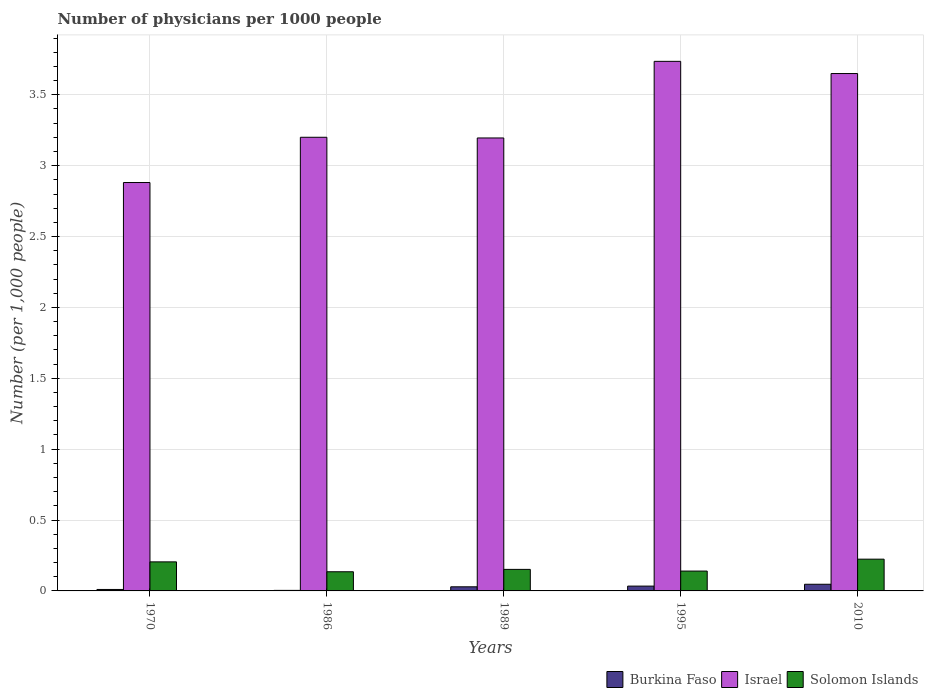What is the number of physicians in Solomon Islands in 2010?
Your answer should be compact. 0.22. Across all years, what is the maximum number of physicians in Burkina Faso?
Your response must be concise. 0.05. Across all years, what is the minimum number of physicians in Israel?
Keep it short and to the point. 2.88. What is the total number of physicians in Solomon Islands in the graph?
Offer a terse response. 0.86. What is the difference between the number of physicians in Solomon Islands in 1995 and that in 2010?
Provide a succinct answer. -0.08. What is the difference between the number of physicians in Solomon Islands in 2010 and the number of physicians in Burkina Faso in 1970?
Keep it short and to the point. 0.21. What is the average number of physicians in Solomon Islands per year?
Your response must be concise. 0.17. In the year 1986, what is the difference between the number of physicians in Burkina Faso and number of physicians in Israel?
Make the answer very short. -3.2. What is the ratio of the number of physicians in Solomon Islands in 1989 to that in 2010?
Make the answer very short. 0.68. Is the number of physicians in Burkina Faso in 1970 less than that in 1986?
Give a very brief answer. No. What is the difference between the highest and the second highest number of physicians in Israel?
Your answer should be very brief. 0.09. What is the difference between the highest and the lowest number of physicians in Solomon Islands?
Provide a short and direct response. 0.09. In how many years, is the number of physicians in Burkina Faso greater than the average number of physicians in Burkina Faso taken over all years?
Ensure brevity in your answer.  3. What does the 1st bar from the left in 1989 represents?
Offer a terse response. Burkina Faso. What does the 3rd bar from the right in 1989 represents?
Ensure brevity in your answer.  Burkina Faso. Is it the case that in every year, the sum of the number of physicians in Burkina Faso and number of physicians in Israel is greater than the number of physicians in Solomon Islands?
Give a very brief answer. Yes. How many bars are there?
Make the answer very short. 15. Are all the bars in the graph horizontal?
Your answer should be compact. No. Does the graph contain grids?
Your response must be concise. Yes. How are the legend labels stacked?
Ensure brevity in your answer.  Horizontal. What is the title of the graph?
Your response must be concise. Number of physicians per 1000 people. What is the label or title of the Y-axis?
Offer a terse response. Number (per 1,0 people). What is the Number (per 1,000 people) in Burkina Faso in 1970?
Offer a terse response. 0.01. What is the Number (per 1,000 people) of Israel in 1970?
Give a very brief answer. 2.88. What is the Number (per 1,000 people) in Solomon Islands in 1970?
Give a very brief answer. 0.2. What is the Number (per 1,000 people) of Burkina Faso in 1986?
Provide a short and direct response. 0. What is the Number (per 1,000 people) of Israel in 1986?
Make the answer very short. 3.2. What is the Number (per 1,000 people) in Solomon Islands in 1986?
Your answer should be very brief. 0.14. What is the Number (per 1,000 people) of Burkina Faso in 1989?
Your response must be concise. 0.03. What is the Number (per 1,000 people) in Israel in 1989?
Make the answer very short. 3.2. What is the Number (per 1,000 people) of Solomon Islands in 1989?
Your answer should be very brief. 0.15. What is the Number (per 1,000 people) of Burkina Faso in 1995?
Provide a succinct answer. 0.03. What is the Number (per 1,000 people) in Israel in 1995?
Your response must be concise. 3.74. What is the Number (per 1,000 people) of Solomon Islands in 1995?
Provide a short and direct response. 0.14. What is the Number (per 1,000 people) in Burkina Faso in 2010?
Provide a short and direct response. 0.05. What is the Number (per 1,000 people) in Israel in 2010?
Keep it short and to the point. 3.65. What is the Number (per 1,000 people) of Solomon Islands in 2010?
Your answer should be compact. 0.22. Across all years, what is the maximum Number (per 1,000 people) of Burkina Faso?
Provide a short and direct response. 0.05. Across all years, what is the maximum Number (per 1,000 people) of Israel?
Make the answer very short. 3.74. Across all years, what is the maximum Number (per 1,000 people) in Solomon Islands?
Ensure brevity in your answer.  0.22. Across all years, what is the minimum Number (per 1,000 people) of Burkina Faso?
Give a very brief answer. 0. Across all years, what is the minimum Number (per 1,000 people) of Israel?
Provide a short and direct response. 2.88. Across all years, what is the minimum Number (per 1,000 people) of Solomon Islands?
Offer a very short reply. 0.14. What is the total Number (per 1,000 people) in Burkina Faso in the graph?
Make the answer very short. 0.12. What is the total Number (per 1,000 people) of Israel in the graph?
Your answer should be very brief. 16.66. What is the total Number (per 1,000 people) in Solomon Islands in the graph?
Offer a terse response. 0.86. What is the difference between the Number (per 1,000 people) in Burkina Faso in 1970 and that in 1986?
Ensure brevity in your answer.  0.01. What is the difference between the Number (per 1,000 people) in Israel in 1970 and that in 1986?
Offer a terse response. -0.32. What is the difference between the Number (per 1,000 people) in Solomon Islands in 1970 and that in 1986?
Ensure brevity in your answer.  0.07. What is the difference between the Number (per 1,000 people) of Burkina Faso in 1970 and that in 1989?
Make the answer very short. -0.02. What is the difference between the Number (per 1,000 people) of Israel in 1970 and that in 1989?
Make the answer very short. -0.31. What is the difference between the Number (per 1,000 people) in Solomon Islands in 1970 and that in 1989?
Provide a succinct answer. 0.05. What is the difference between the Number (per 1,000 people) of Burkina Faso in 1970 and that in 1995?
Offer a very short reply. -0.02. What is the difference between the Number (per 1,000 people) of Israel in 1970 and that in 1995?
Ensure brevity in your answer.  -0.85. What is the difference between the Number (per 1,000 people) of Solomon Islands in 1970 and that in 1995?
Give a very brief answer. 0.07. What is the difference between the Number (per 1,000 people) of Burkina Faso in 1970 and that in 2010?
Keep it short and to the point. -0.04. What is the difference between the Number (per 1,000 people) in Israel in 1970 and that in 2010?
Provide a short and direct response. -0.77. What is the difference between the Number (per 1,000 people) of Solomon Islands in 1970 and that in 2010?
Your answer should be compact. -0.02. What is the difference between the Number (per 1,000 people) in Burkina Faso in 1986 and that in 1989?
Provide a short and direct response. -0.03. What is the difference between the Number (per 1,000 people) in Israel in 1986 and that in 1989?
Offer a terse response. 0. What is the difference between the Number (per 1,000 people) in Solomon Islands in 1986 and that in 1989?
Keep it short and to the point. -0.02. What is the difference between the Number (per 1,000 people) in Burkina Faso in 1986 and that in 1995?
Ensure brevity in your answer.  -0.03. What is the difference between the Number (per 1,000 people) of Israel in 1986 and that in 1995?
Give a very brief answer. -0.54. What is the difference between the Number (per 1,000 people) in Solomon Islands in 1986 and that in 1995?
Make the answer very short. -0. What is the difference between the Number (per 1,000 people) of Burkina Faso in 1986 and that in 2010?
Your answer should be very brief. -0.04. What is the difference between the Number (per 1,000 people) in Israel in 1986 and that in 2010?
Provide a short and direct response. -0.45. What is the difference between the Number (per 1,000 people) in Solomon Islands in 1986 and that in 2010?
Your answer should be compact. -0.09. What is the difference between the Number (per 1,000 people) of Burkina Faso in 1989 and that in 1995?
Make the answer very short. -0.01. What is the difference between the Number (per 1,000 people) of Israel in 1989 and that in 1995?
Provide a short and direct response. -0.54. What is the difference between the Number (per 1,000 people) in Solomon Islands in 1989 and that in 1995?
Your answer should be compact. 0.01. What is the difference between the Number (per 1,000 people) in Burkina Faso in 1989 and that in 2010?
Your response must be concise. -0.02. What is the difference between the Number (per 1,000 people) in Israel in 1989 and that in 2010?
Keep it short and to the point. -0.45. What is the difference between the Number (per 1,000 people) of Solomon Islands in 1989 and that in 2010?
Your response must be concise. -0.07. What is the difference between the Number (per 1,000 people) of Burkina Faso in 1995 and that in 2010?
Offer a terse response. -0.01. What is the difference between the Number (per 1,000 people) of Israel in 1995 and that in 2010?
Make the answer very short. 0.09. What is the difference between the Number (per 1,000 people) in Solomon Islands in 1995 and that in 2010?
Ensure brevity in your answer.  -0.08. What is the difference between the Number (per 1,000 people) of Burkina Faso in 1970 and the Number (per 1,000 people) of Israel in 1986?
Provide a short and direct response. -3.19. What is the difference between the Number (per 1,000 people) of Burkina Faso in 1970 and the Number (per 1,000 people) of Solomon Islands in 1986?
Give a very brief answer. -0.12. What is the difference between the Number (per 1,000 people) in Israel in 1970 and the Number (per 1,000 people) in Solomon Islands in 1986?
Offer a terse response. 2.75. What is the difference between the Number (per 1,000 people) of Burkina Faso in 1970 and the Number (per 1,000 people) of Israel in 1989?
Your answer should be very brief. -3.19. What is the difference between the Number (per 1,000 people) in Burkina Faso in 1970 and the Number (per 1,000 people) in Solomon Islands in 1989?
Provide a succinct answer. -0.14. What is the difference between the Number (per 1,000 people) of Israel in 1970 and the Number (per 1,000 people) of Solomon Islands in 1989?
Provide a succinct answer. 2.73. What is the difference between the Number (per 1,000 people) of Burkina Faso in 1970 and the Number (per 1,000 people) of Israel in 1995?
Offer a very short reply. -3.73. What is the difference between the Number (per 1,000 people) of Burkina Faso in 1970 and the Number (per 1,000 people) of Solomon Islands in 1995?
Offer a very short reply. -0.13. What is the difference between the Number (per 1,000 people) in Israel in 1970 and the Number (per 1,000 people) in Solomon Islands in 1995?
Your response must be concise. 2.74. What is the difference between the Number (per 1,000 people) in Burkina Faso in 1970 and the Number (per 1,000 people) in Israel in 2010?
Your response must be concise. -3.64. What is the difference between the Number (per 1,000 people) of Burkina Faso in 1970 and the Number (per 1,000 people) of Solomon Islands in 2010?
Ensure brevity in your answer.  -0.21. What is the difference between the Number (per 1,000 people) of Israel in 1970 and the Number (per 1,000 people) of Solomon Islands in 2010?
Your answer should be compact. 2.66. What is the difference between the Number (per 1,000 people) in Burkina Faso in 1986 and the Number (per 1,000 people) in Israel in 1989?
Offer a very short reply. -3.19. What is the difference between the Number (per 1,000 people) in Burkina Faso in 1986 and the Number (per 1,000 people) in Solomon Islands in 1989?
Offer a very short reply. -0.15. What is the difference between the Number (per 1,000 people) in Israel in 1986 and the Number (per 1,000 people) in Solomon Islands in 1989?
Give a very brief answer. 3.05. What is the difference between the Number (per 1,000 people) in Burkina Faso in 1986 and the Number (per 1,000 people) in Israel in 1995?
Your answer should be compact. -3.73. What is the difference between the Number (per 1,000 people) of Burkina Faso in 1986 and the Number (per 1,000 people) of Solomon Islands in 1995?
Your answer should be very brief. -0.14. What is the difference between the Number (per 1,000 people) of Israel in 1986 and the Number (per 1,000 people) of Solomon Islands in 1995?
Offer a very short reply. 3.06. What is the difference between the Number (per 1,000 people) in Burkina Faso in 1986 and the Number (per 1,000 people) in Israel in 2010?
Offer a terse response. -3.65. What is the difference between the Number (per 1,000 people) in Burkina Faso in 1986 and the Number (per 1,000 people) in Solomon Islands in 2010?
Your answer should be very brief. -0.22. What is the difference between the Number (per 1,000 people) of Israel in 1986 and the Number (per 1,000 people) of Solomon Islands in 2010?
Keep it short and to the point. 2.98. What is the difference between the Number (per 1,000 people) in Burkina Faso in 1989 and the Number (per 1,000 people) in Israel in 1995?
Provide a short and direct response. -3.71. What is the difference between the Number (per 1,000 people) of Burkina Faso in 1989 and the Number (per 1,000 people) of Solomon Islands in 1995?
Provide a short and direct response. -0.11. What is the difference between the Number (per 1,000 people) of Israel in 1989 and the Number (per 1,000 people) of Solomon Islands in 1995?
Offer a terse response. 3.06. What is the difference between the Number (per 1,000 people) of Burkina Faso in 1989 and the Number (per 1,000 people) of Israel in 2010?
Provide a succinct answer. -3.62. What is the difference between the Number (per 1,000 people) in Burkina Faso in 1989 and the Number (per 1,000 people) in Solomon Islands in 2010?
Offer a very short reply. -0.2. What is the difference between the Number (per 1,000 people) of Israel in 1989 and the Number (per 1,000 people) of Solomon Islands in 2010?
Your response must be concise. 2.97. What is the difference between the Number (per 1,000 people) of Burkina Faso in 1995 and the Number (per 1,000 people) of Israel in 2010?
Your response must be concise. -3.62. What is the difference between the Number (per 1,000 people) in Burkina Faso in 1995 and the Number (per 1,000 people) in Solomon Islands in 2010?
Give a very brief answer. -0.19. What is the difference between the Number (per 1,000 people) of Israel in 1995 and the Number (per 1,000 people) of Solomon Islands in 2010?
Provide a short and direct response. 3.51. What is the average Number (per 1,000 people) in Burkina Faso per year?
Make the answer very short. 0.02. What is the average Number (per 1,000 people) of Israel per year?
Ensure brevity in your answer.  3.33. What is the average Number (per 1,000 people) in Solomon Islands per year?
Your response must be concise. 0.17. In the year 1970, what is the difference between the Number (per 1,000 people) of Burkina Faso and Number (per 1,000 people) of Israel?
Make the answer very short. -2.87. In the year 1970, what is the difference between the Number (per 1,000 people) in Burkina Faso and Number (per 1,000 people) in Solomon Islands?
Keep it short and to the point. -0.19. In the year 1970, what is the difference between the Number (per 1,000 people) of Israel and Number (per 1,000 people) of Solomon Islands?
Offer a very short reply. 2.68. In the year 1986, what is the difference between the Number (per 1,000 people) in Burkina Faso and Number (per 1,000 people) in Israel?
Offer a very short reply. -3.2. In the year 1986, what is the difference between the Number (per 1,000 people) of Burkina Faso and Number (per 1,000 people) of Solomon Islands?
Provide a short and direct response. -0.13. In the year 1986, what is the difference between the Number (per 1,000 people) in Israel and Number (per 1,000 people) in Solomon Islands?
Give a very brief answer. 3.07. In the year 1989, what is the difference between the Number (per 1,000 people) in Burkina Faso and Number (per 1,000 people) in Israel?
Make the answer very short. -3.17. In the year 1989, what is the difference between the Number (per 1,000 people) in Burkina Faso and Number (per 1,000 people) in Solomon Islands?
Provide a short and direct response. -0.12. In the year 1989, what is the difference between the Number (per 1,000 people) of Israel and Number (per 1,000 people) of Solomon Islands?
Your answer should be compact. 3.04. In the year 1995, what is the difference between the Number (per 1,000 people) of Burkina Faso and Number (per 1,000 people) of Israel?
Offer a very short reply. -3.7. In the year 1995, what is the difference between the Number (per 1,000 people) in Burkina Faso and Number (per 1,000 people) in Solomon Islands?
Make the answer very short. -0.11. In the year 1995, what is the difference between the Number (per 1,000 people) of Israel and Number (per 1,000 people) of Solomon Islands?
Offer a very short reply. 3.6. In the year 2010, what is the difference between the Number (per 1,000 people) of Burkina Faso and Number (per 1,000 people) of Israel?
Provide a succinct answer. -3.6. In the year 2010, what is the difference between the Number (per 1,000 people) of Burkina Faso and Number (per 1,000 people) of Solomon Islands?
Your answer should be compact. -0.18. In the year 2010, what is the difference between the Number (per 1,000 people) of Israel and Number (per 1,000 people) of Solomon Islands?
Ensure brevity in your answer.  3.43. What is the ratio of the Number (per 1,000 people) in Burkina Faso in 1970 to that in 1986?
Your answer should be very brief. 2.71. What is the ratio of the Number (per 1,000 people) of Israel in 1970 to that in 1986?
Give a very brief answer. 0.9. What is the ratio of the Number (per 1,000 people) of Solomon Islands in 1970 to that in 1986?
Offer a terse response. 1.52. What is the ratio of the Number (per 1,000 people) of Burkina Faso in 1970 to that in 1989?
Provide a succinct answer. 0.36. What is the ratio of the Number (per 1,000 people) of Israel in 1970 to that in 1989?
Provide a succinct answer. 0.9. What is the ratio of the Number (per 1,000 people) of Solomon Islands in 1970 to that in 1989?
Offer a very short reply. 1.35. What is the ratio of the Number (per 1,000 people) of Burkina Faso in 1970 to that in 1995?
Provide a short and direct response. 0.3. What is the ratio of the Number (per 1,000 people) of Israel in 1970 to that in 1995?
Offer a very short reply. 0.77. What is the ratio of the Number (per 1,000 people) of Solomon Islands in 1970 to that in 1995?
Provide a short and direct response. 1.46. What is the ratio of the Number (per 1,000 people) of Burkina Faso in 1970 to that in 2010?
Provide a succinct answer. 0.22. What is the ratio of the Number (per 1,000 people) of Israel in 1970 to that in 2010?
Offer a terse response. 0.79. What is the ratio of the Number (per 1,000 people) of Solomon Islands in 1970 to that in 2010?
Give a very brief answer. 0.92. What is the ratio of the Number (per 1,000 people) in Burkina Faso in 1986 to that in 1989?
Keep it short and to the point. 0.13. What is the ratio of the Number (per 1,000 people) in Israel in 1986 to that in 1989?
Ensure brevity in your answer.  1. What is the ratio of the Number (per 1,000 people) in Solomon Islands in 1986 to that in 1989?
Provide a short and direct response. 0.89. What is the ratio of the Number (per 1,000 people) in Burkina Faso in 1986 to that in 1995?
Provide a succinct answer. 0.11. What is the ratio of the Number (per 1,000 people) of Israel in 1986 to that in 1995?
Offer a very short reply. 0.86. What is the ratio of the Number (per 1,000 people) in Solomon Islands in 1986 to that in 1995?
Your answer should be very brief. 0.97. What is the ratio of the Number (per 1,000 people) of Burkina Faso in 1986 to that in 2010?
Your answer should be compact. 0.08. What is the ratio of the Number (per 1,000 people) of Israel in 1986 to that in 2010?
Keep it short and to the point. 0.88. What is the ratio of the Number (per 1,000 people) in Solomon Islands in 1986 to that in 2010?
Make the answer very short. 0.6. What is the ratio of the Number (per 1,000 people) in Burkina Faso in 1989 to that in 1995?
Your answer should be compact. 0.85. What is the ratio of the Number (per 1,000 people) in Israel in 1989 to that in 1995?
Your response must be concise. 0.86. What is the ratio of the Number (per 1,000 people) in Solomon Islands in 1989 to that in 1995?
Make the answer very short. 1.09. What is the ratio of the Number (per 1,000 people) of Burkina Faso in 1989 to that in 2010?
Your response must be concise. 0.62. What is the ratio of the Number (per 1,000 people) of Israel in 1989 to that in 2010?
Keep it short and to the point. 0.88. What is the ratio of the Number (per 1,000 people) of Solomon Islands in 1989 to that in 2010?
Provide a succinct answer. 0.68. What is the ratio of the Number (per 1,000 people) of Burkina Faso in 1995 to that in 2010?
Provide a short and direct response. 0.72. What is the ratio of the Number (per 1,000 people) in Israel in 1995 to that in 2010?
Keep it short and to the point. 1.02. What is the ratio of the Number (per 1,000 people) of Solomon Islands in 1995 to that in 2010?
Your response must be concise. 0.62. What is the difference between the highest and the second highest Number (per 1,000 people) in Burkina Faso?
Offer a very short reply. 0.01. What is the difference between the highest and the second highest Number (per 1,000 people) of Israel?
Your response must be concise. 0.09. What is the difference between the highest and the second highest Number (per 1,000 people) of Solomon Islands?
Offer a very short reply. 0.02. What is the difference between the highest and the lowest Number (per 1,000 people) of Burkina Faso?
Your response must be concise. 0.04. What is the difference between the highest and the lowest Number (per 1,000 people) of Israel?
Ensure brevity in your answer.  0.85. What is the difference between the highest and the lowest Number (per 1,000 people) in Solomon Islands?
Provide a short and direct response. 0.09. 